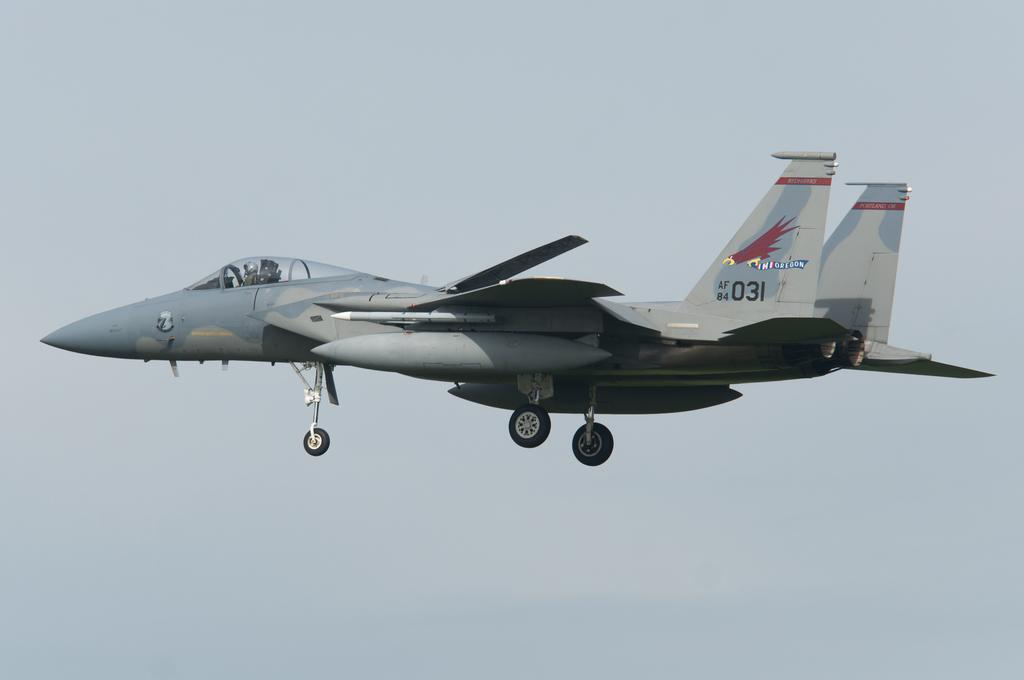<image>
Share a concise interpretation of the image provided. a military jet in the sky with AF 84 031 on its tailfin 